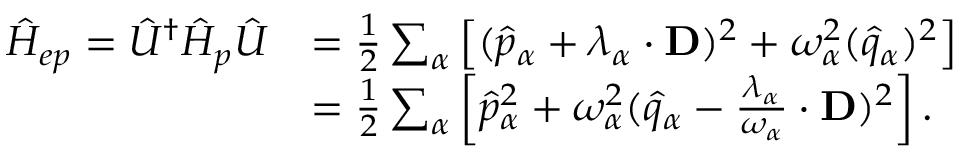Convert formula to latex. <formula><loc_0><loc_0><loc_500><loc_500>\begin{array} { r l } { \hat { H } _ { e p } = \hat { U } ^ { \dag } \hat { H } _ { p } \hat { U } } & { = \frac { 1 } { 2 } \sum _ { \alpha } \left [ ( \hat { p } _ { \alpha } + \lambda _ { \alpha } \cdot D ) ^ { 2 } + \omega _ { \alpha } ^ { 2 } ( \hat { q } _ { \alpha } ) ^ { 2 } \right ] } \\ & { = \frac { 1 } { 2 } \sum _ { \alpha } \left [ \hat { p } _ { \alpha } ^ { 2 } + \omega _ { \alpha } ^ { 2 } ( \hat { q } _ { \alpha } - \frac { \lambda _ { \alpha } } { \omega _ { \alpha } } \cdot D ) ^ { 2 } \right ] . } \end{array}</formula> 